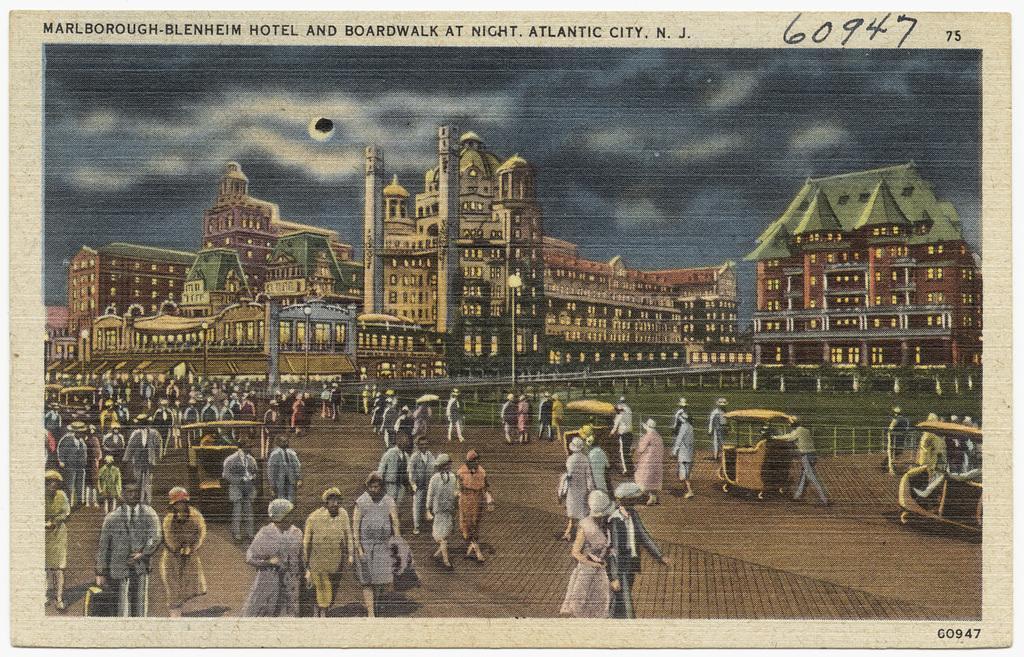Describe this image in one or two sentences. In this image we can see a picture. In the picture there are sky with clouds, buildings, street poles, street lights, carts and persons walking on the road. 